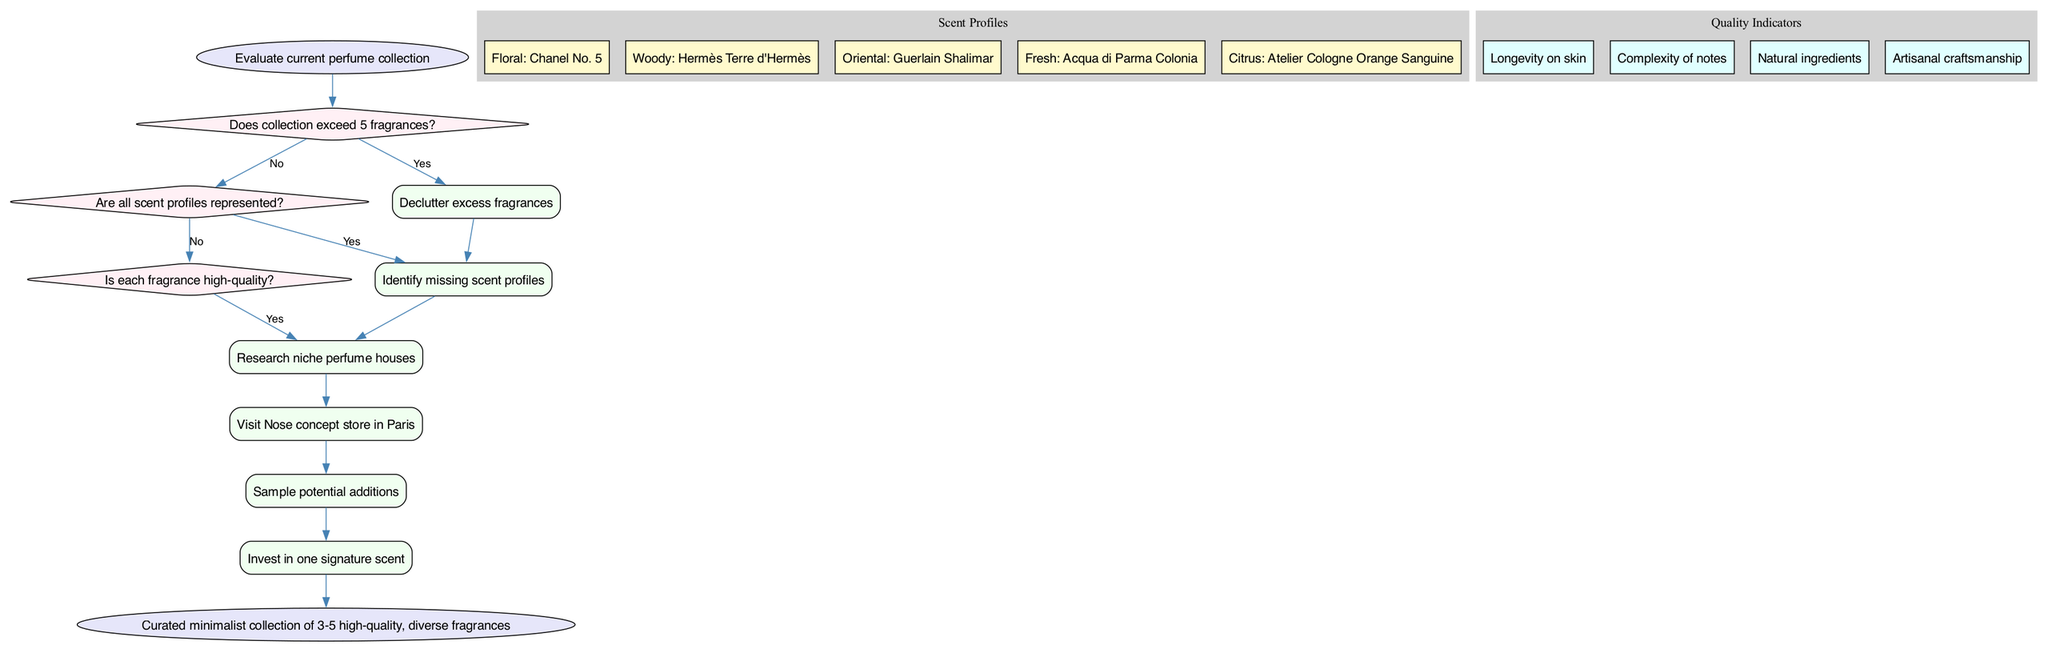What is the initial assessment in the pathway? The initial assessment in the pathway is the first node, which evaluates the current perfume collection. This is identified as "Evaluate current perfume collection" in the diagram.
Answer: Evaluate current perfume collection How many action nodes are present in the diagram? By counting the nodes specifically categorized under actions, there are 6 actions listed in the diagram. Each action is represented distinctly, contributing to the total count.
Answer: 6 What does the first decision point ask about the collection? The first decision point in the diagram questions if the collection exceeds 5 fragrances. This is the first key decision in the pathway that influences subsequent actions.
Answer: Does collection exceed 5 fragrances? Which scent profile is associated with the fragrance "Chanel No. 5"? The scent profile connected to "Chanel No. 5" is "Floral." This is listed within the scent profiles cluster in the diagram, clearly identifying the scent category for this fragrance.
Answer: Floral What action follows after identifying missing scent profiles? The action that follows after identifying missing scent profiles is to research niche perfume houses. The flow of the diagram connects these actions sequentially.
Answer: Research niche perfume houses How does the pathway determine the final outcome? The final outcome is determined after the last action node, which culminates from the series of decisions and actions taken throughout the pathway. In this case, it leads to the outcome of a curated minimalist collection of 3-5 high-quality, diverse fragrances.
Answer: Curated minimalist collection of 3-5 high-quality, diverse fragrances What quality indicator is mentioned first in the quality indicators cluster? The first quality indicator mentioned in the quality indicators cluster is "Longevity on skin." This is the first quality aspect evaluated in determining the quality of fragrances.
Answer: Longevity on skin How many scent profiles are represented in the diagram? The diagram represents a total of 5 distinct scent profiles associated with various fragrances, as outlined within the scent profiles section of the clinical pathway.
Answer: 5 